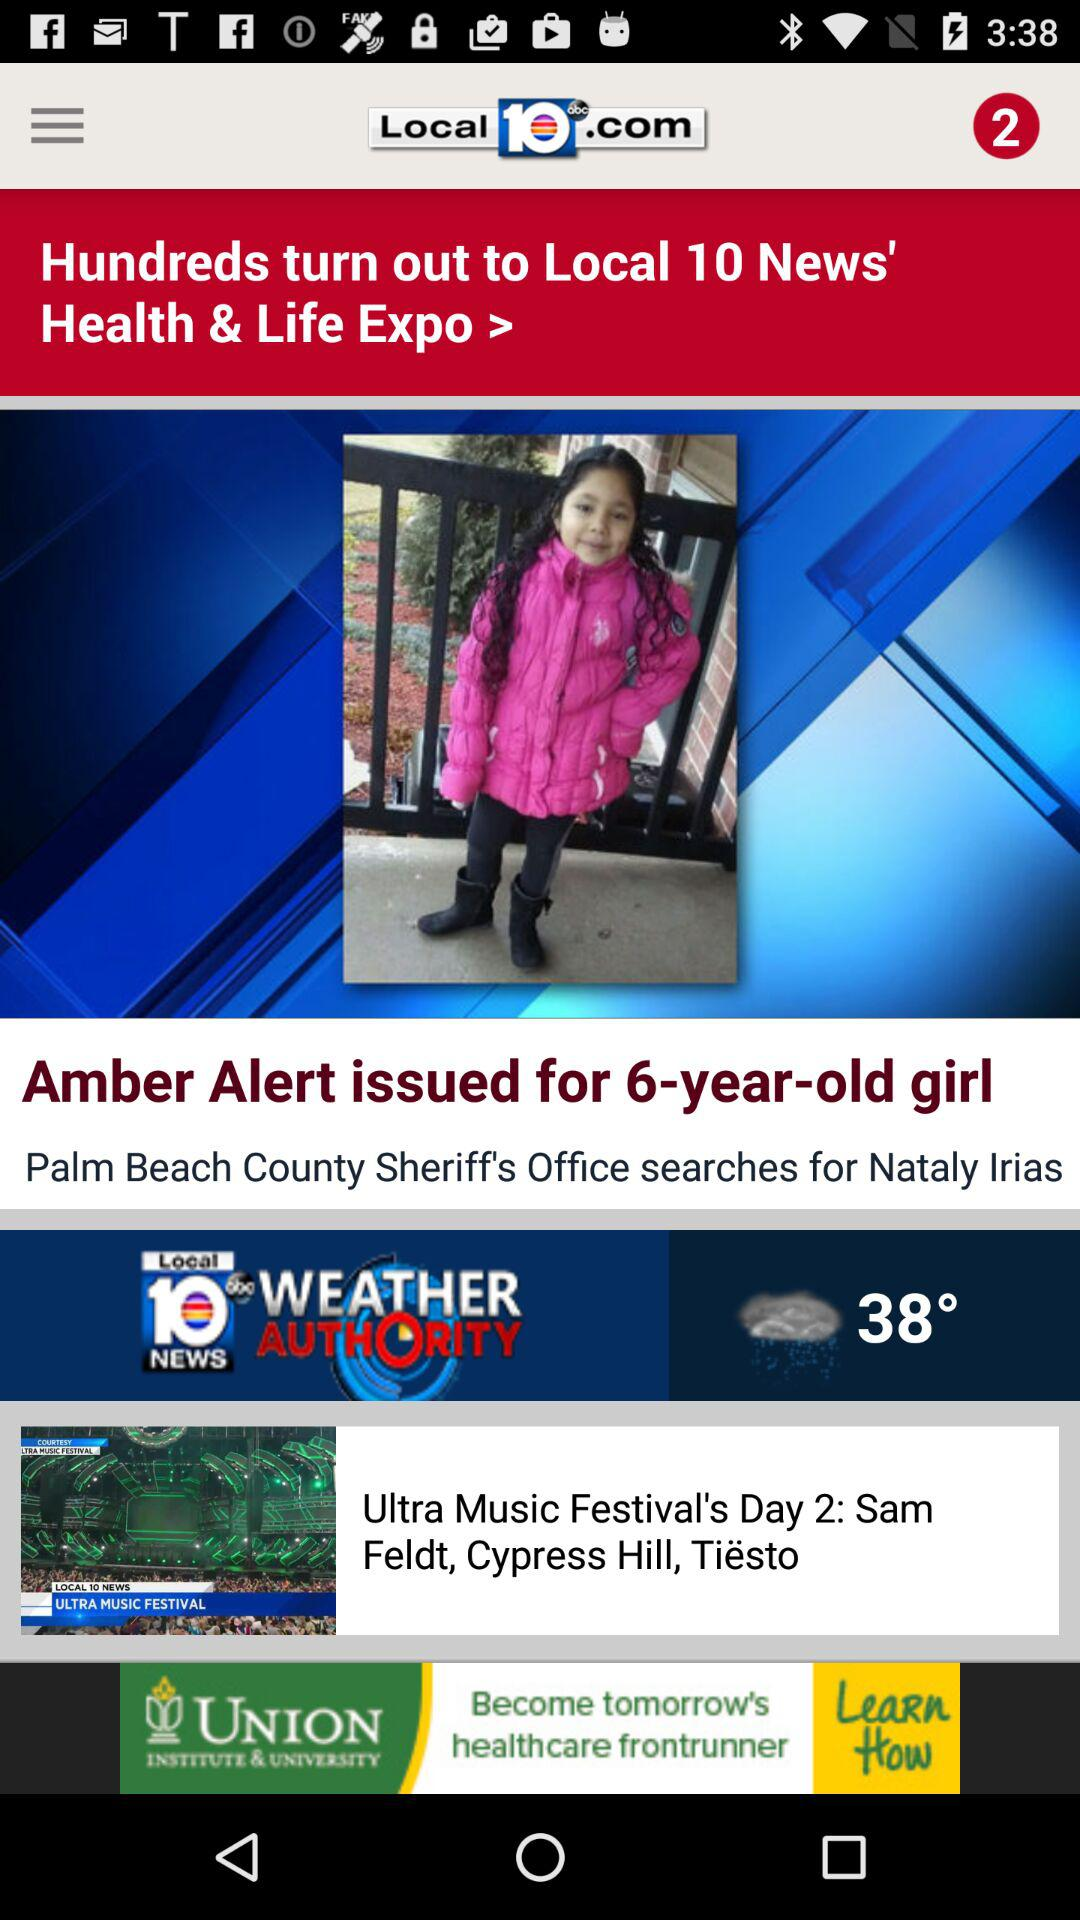What alert is issued for the 6-year-old girl? For the 6-year-old girl, the Amber alert is issued. 